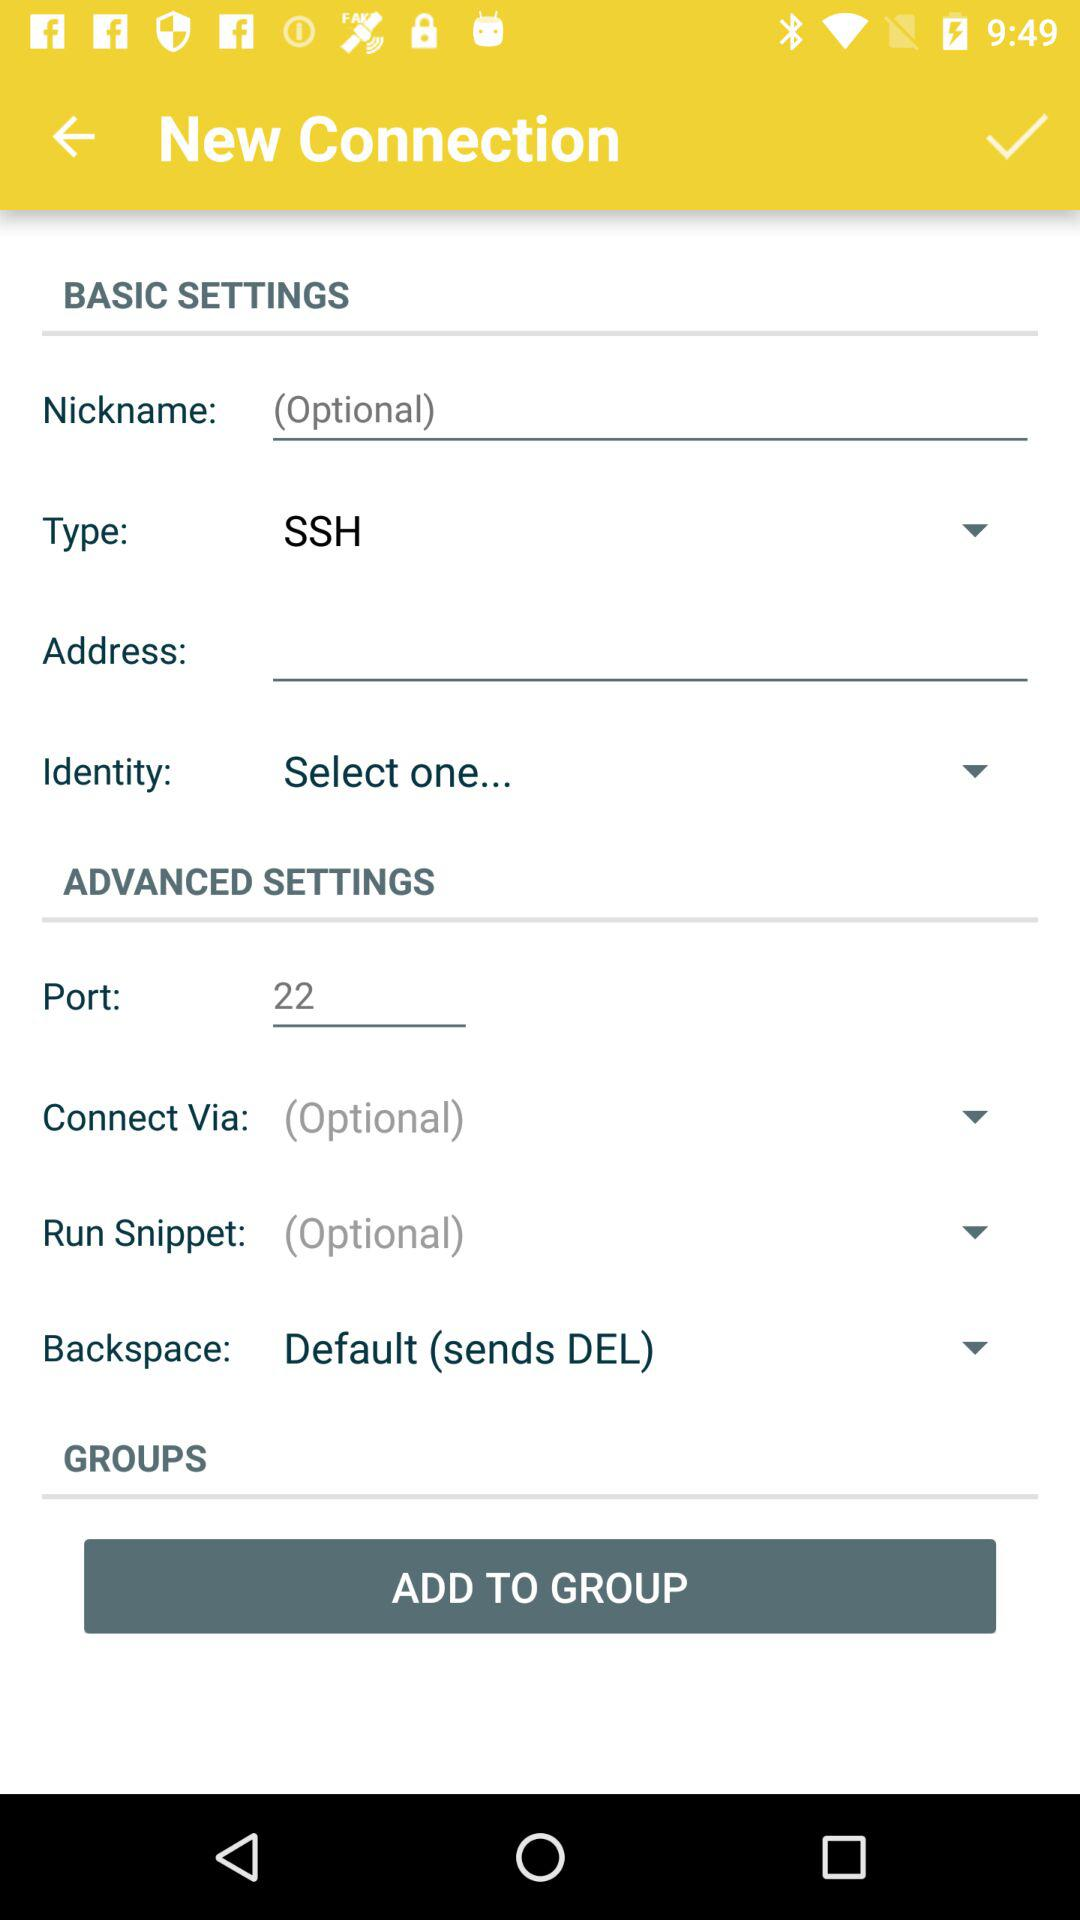What's the backspace? The backspace is "Default (sends DEL)". 